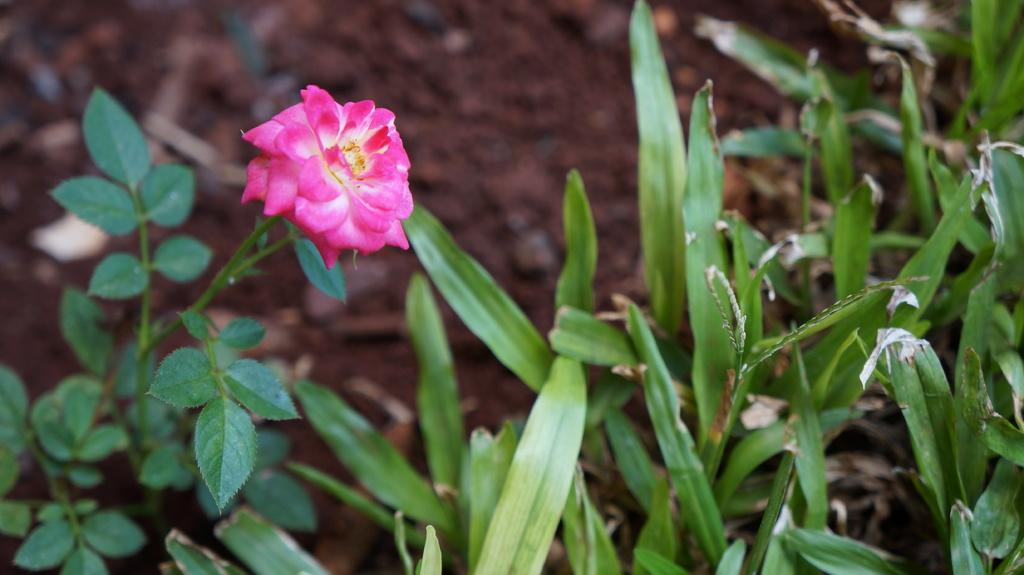What type of plant is visible in the image? There is a flower in the image. Are there any other plants present in the image? Yes, there are plants in the image. Can you describe the background of the image? The background of the image is blurred. What type of wire is holding the jelly in the image? There is no wire or jelly present in the image. 